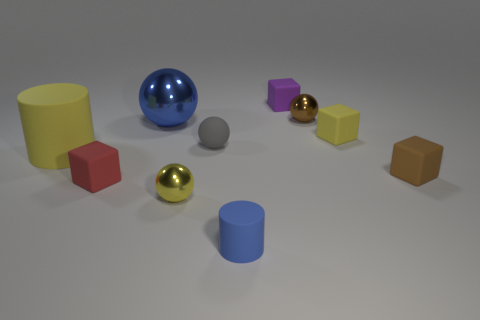There is a ball that is both left of the tiny matte cylinder and behind the tiny yellow cube; what color is it?
Offer a terse response. Blue. Are there fewer big yellow objects than small brown things?
Keep it short and to the point. Yes. There is a tiny cylinder; does it have the same color as the large object behind the gray sphere?
Give a very brief answer. Yes. Are there an equal number of big blue balls right of the tiny blue cylinder and big things in front of the big metal ball?
Give a very brief answer. No. What number of blue metal things have the same shape as the purple object?
Your answer should be compact. 0. Are there any big brown cylinders?
Offer a very short reply. No. Does the gray object have the same material as the cylinder in front of the small brown matte object?
Make the answer very short. Yes. What material is the cylinder that is the same size as the gray sphere?
Ensure brevity in your answer.  Rubber. Are there any large objects that have the same material as the large yellow cylinder?
Keep it short and to the point. No. There is a yellow rubber thing to the left of the shiny sphere that is to the right of the rubber ball; is there a yellow sphere on the right side of it?
Keep it short and to the point. Yes. 